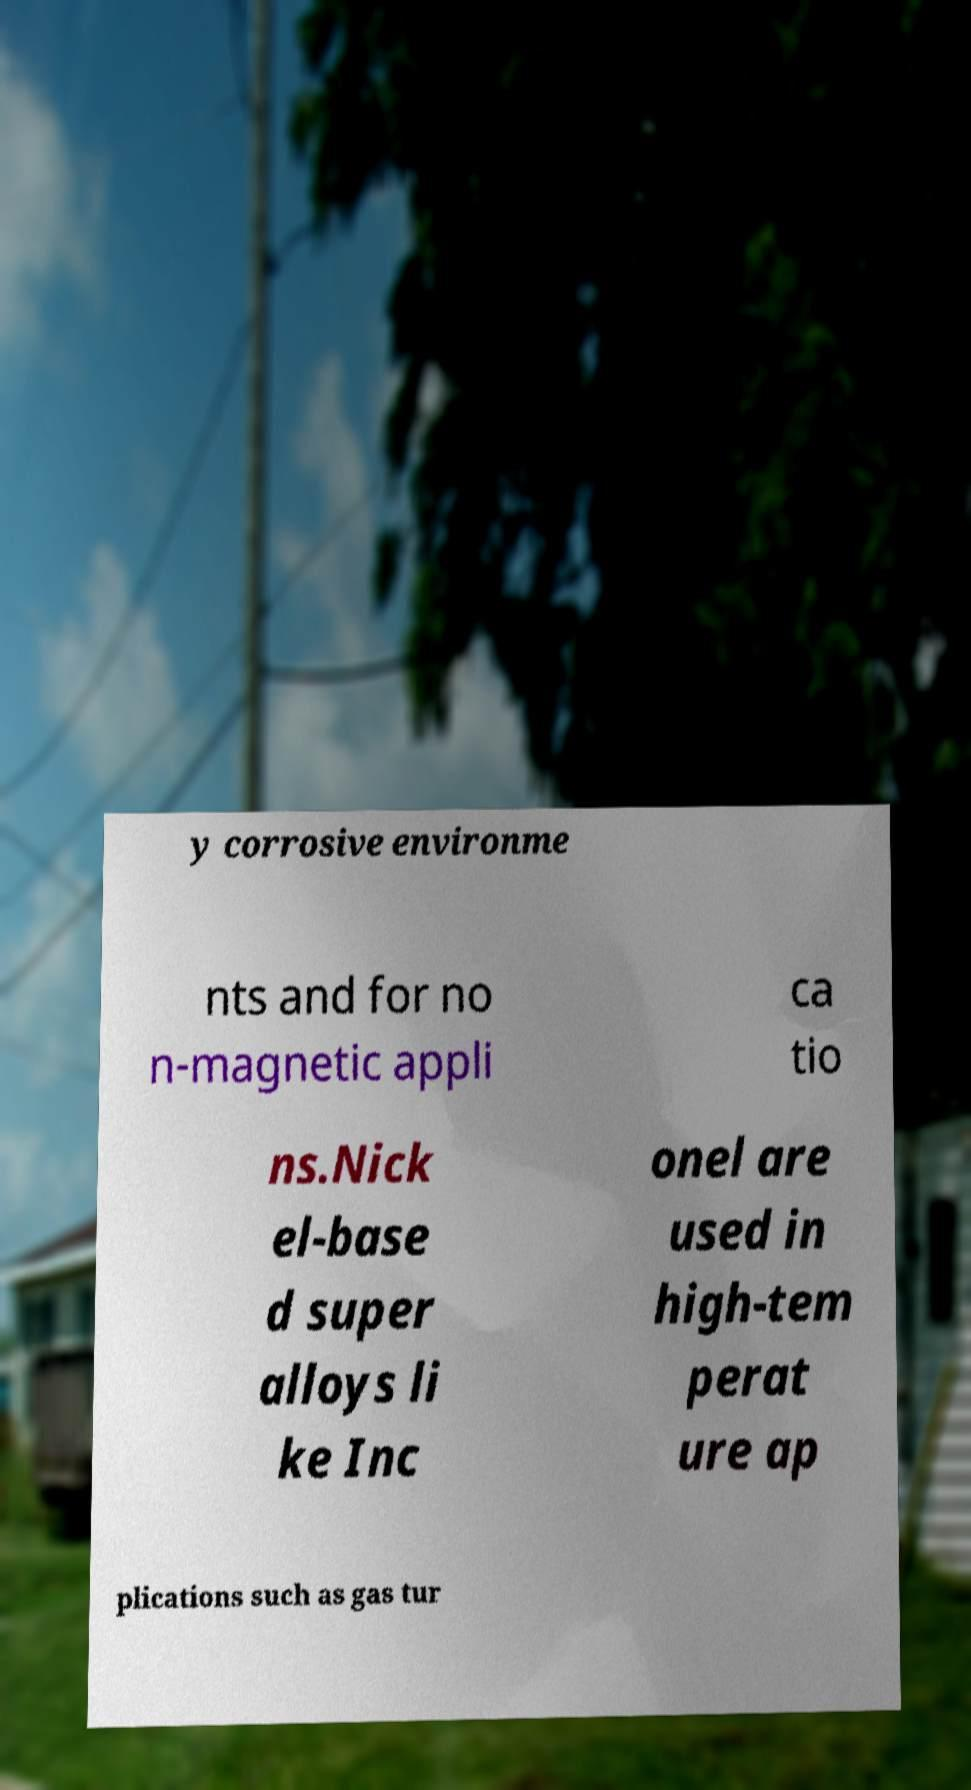Please read and relay the text visible in this image. What does it say? y corrosive environme nts and for no n-magnetic appli ca tio ns.Nick el-base d super alloys li ke Inc onel are used in high-tem perat ure ap plications such as gas tur 